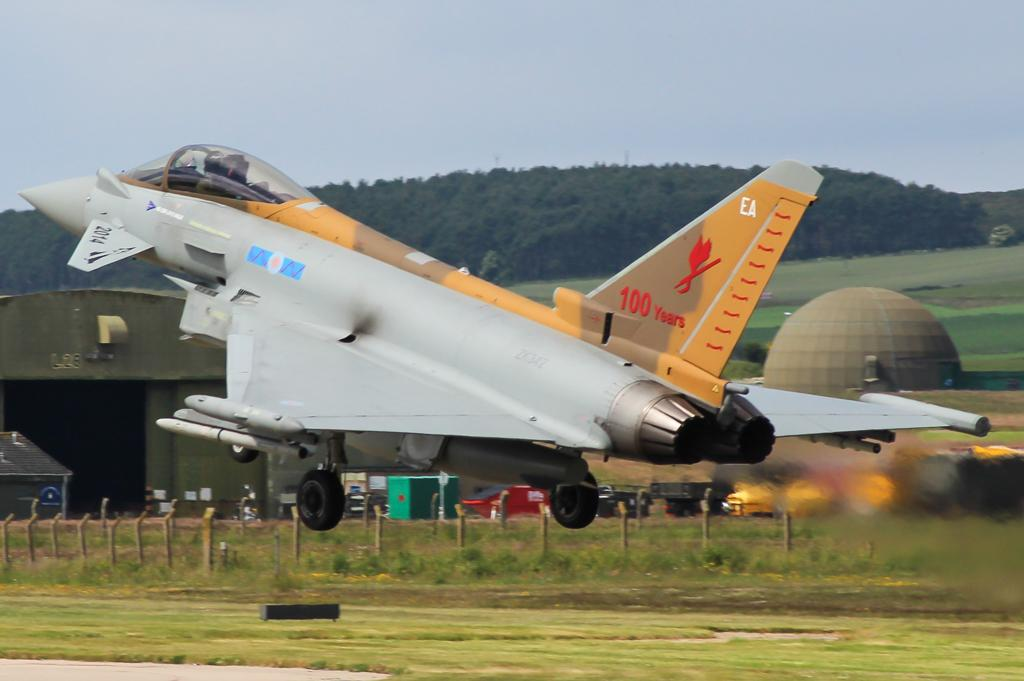What is the main subject of the image? The main subject of the image is an airplane. What structures can be seen in the image? There are poles, sheds, and a dome visible in the image. What type of vehicles are present in the image? There are vehicles in the image. What objects are on the ground in the image? There are objects on the ground in the image. What can be seen in the background of the image? There are trees and sky visible in the background of the image. How many cents are visible on the airplane in the image? There are no cents visible on the airplane in the image. What type of bubble can be seen floating near the dome in the image? There are no bubbles present in the image. 